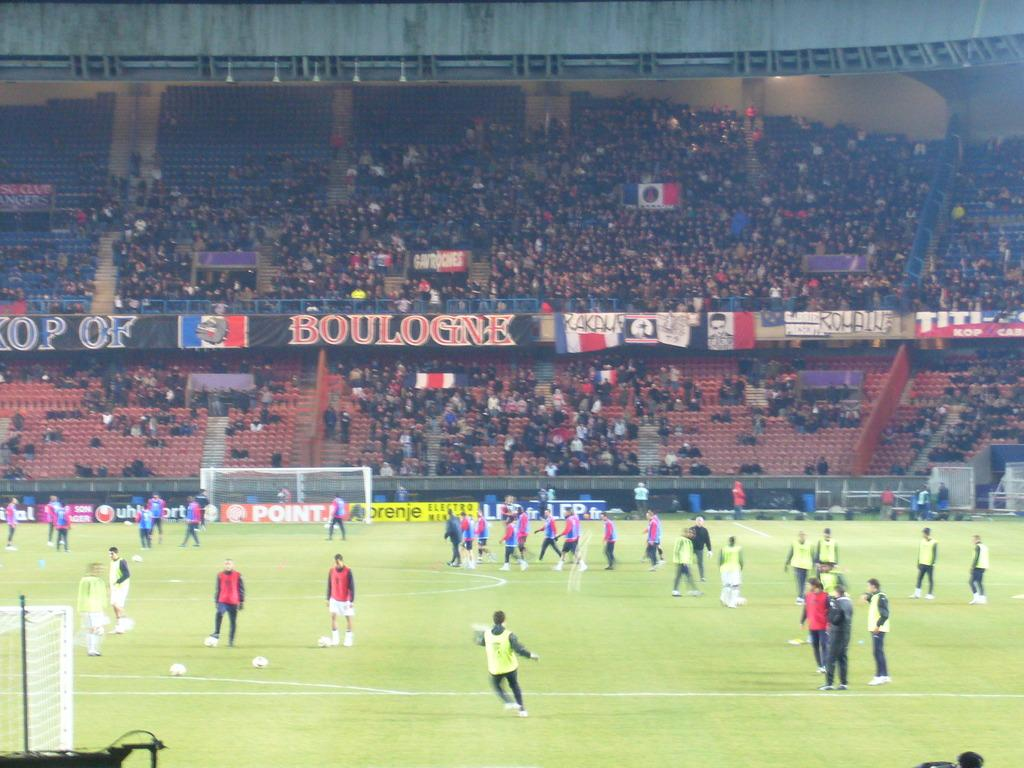How many persons can be seen in the image? There are persons in the image, but the exact number is not specified. What objects are on the ground in the image? There are footballs on the ground in the image. What structures are present in the image? There are nets in the image. What can be seen in the background of the image? In the background of the image, there is an audience, empty chairs, hoardings, a wall, and other objects. What type of butter is being spread on the stream in the image? There is no butter or stream present in the image. How many thumbs are visible in the image? The number of thumbs visible in the image is not specified, and thumbs are not mentioned in the provided facts. 